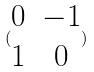<formula> <loc_0><loc_0><loc_500><loc_500>( \begin{matrix} 0 & - 1 \\ 1 & 0 \end{matrix} )</formula> 